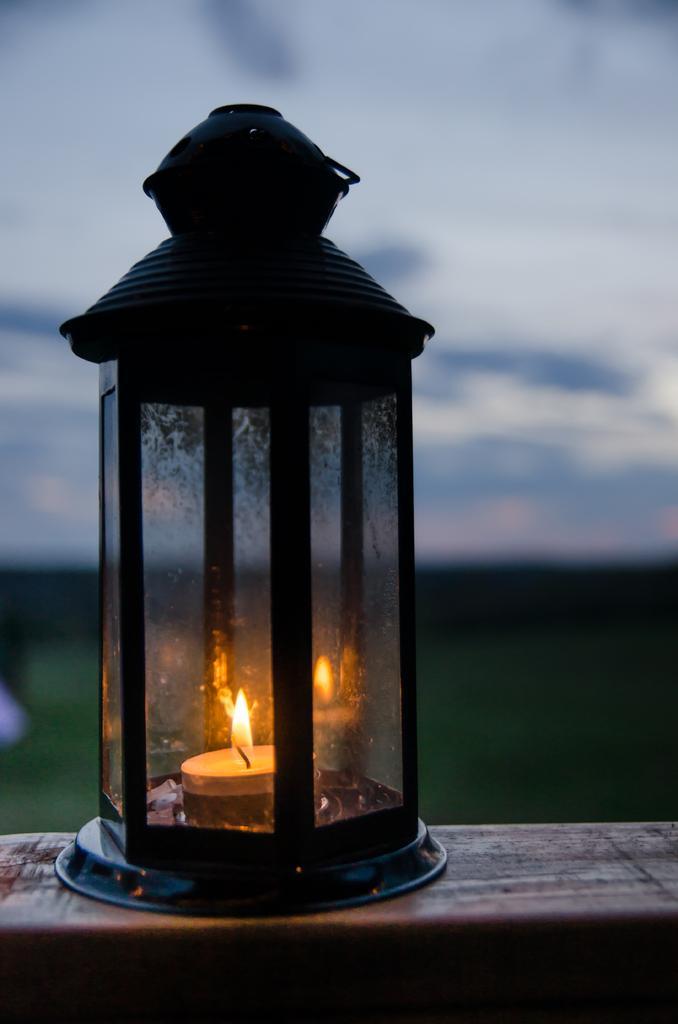Can you describe this image briefly? In this picture we can see a lantern on the wooden surface. 